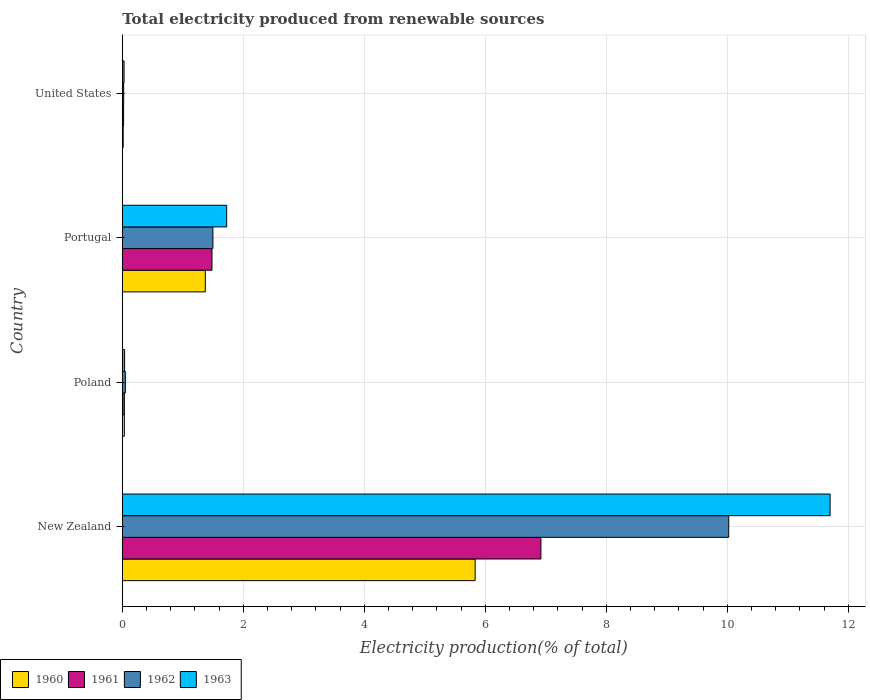Are the number of bars per tick equal to the number of legend labels?
Your answer should be compact. Yes. Are the number of bars on each tick of the Y-axis equal?
Your answer should be very brief. Yes. How many bars are there on the 2nd tick from the top?
Your answer should be compact. 4. What is the total electricity produced in 1963 in New Zealand?
Offer a terse response. 11.7. Across all countries, what is the maximum total electricity produced in 1961?
Make the answer very short. 6.92. Across all countries, what is the minimum total electricity produced in 1961?
Provide a succinct answer. 0.02. In which country was the total electricity produced in 1960 maximum?
Your answer should be compact. New Zealand. In which country was the total electricity produced in 1963 minimum?
Ensure brevity in your answer.  United States. What is the total total electricity produced in 1962 in the graph?
Ensure brevity in your answer.  11.6. What is the difference between the total electricity produced in 1963 in Portugal and that in United States?
Keep it short and to the point. 1.7. What is the difference between the total electricity produced in 1960 in Portugal and the total electricity produced in 1962 in New Zealand?
Keep it short and to the point. -8.65. What is the average total electricity produced in 1963 per country?
Provide a succinct answer. 3.37. What is the difference between the total electricity produced in 1960 and total electricity produced in 1961 in Poland?
Keep it short and to the point. 3.156606850160393e-5. What is the ratio of the total electricity produced in 1961 in Portugal to that in United States?
Your answer should be compact. 68.83. Is the total electricity produced in 1960 in Portugal less than that in United States?
Your response must be concise. No. What is the difference between the highest and the second highest total electricity produced in 1962?
Make the answer very short. 8.53. What is the difference between the highest and the lowest total electricity produced in 1961?
Ensure brevity in your answer.  6.9. In how many countries, is the total electricity produced in 1962 greater than the average total electricity produced in 1962 taken over all countries?
Ensure brevity in your answer.  1. Is it the case that in every country, the sum of the total electricity produced in 1963 and total electricity produced in 1961 is greater than the total electricity produced in 1960?
Keep it short and to the point. Yes. Are all the bars in the graph horizontal?
Make the answer very short. Yes. How many countries are there in the graph?
Give a very brief answer. 4. What is the difference between two consecutive major ticks on the X-axis?
Provide a succinct answer. 2. Are the values on the major ticks of X-axis written in scientific E-notation?
Offer a terse response. No. Does the graph contain grids?
Give a very brief answer. Yes. How many legend labels are there?
Provide a succinct answer. 4. What is the title of the graph?
Offer a terse response. Total electricity produced from renewable sources. What is the label or title of the X-axis?
Make the answer very short. Electricity production(% of total). What is the Electricity production(% of total) in 1960 in New Zealand?
Your answer should be compact. 5.83. What is the Electricity production(% of total) of 1961 in New Zealand?
Give a very brief answer. 6.92. What is the Electricity production(% of total) of 1962 in New Zealand?
Provide a succinct answer. 10.02. What is the Electricity production(% of total) of 1963 in New Zealand?
Your response must be concise. 11.7. What is the Electricity production(% of total) of 1960 in Poland?
Your response must be concise. 0.03. What is the Electricity production(% of total) of 1961 in Poland?
Your response must be concise. 0.03. What is the Electricity production(% of total) of 1962 in Poland?
Keep it short and to the point. 0.05. What is the Electricity production(% of total) of 1963 in Poland?
Your answer should be very brief. 0.04. What is the Electricity production(% of total) of 1960 in Portugal?
Keep it short and to the point. 1.37. What is the Electricity production(% of total) in 1961 in Portugal?
Ensure brevity in your answer.  1.48. What is the Electricity production(% of total) of 1962 in Portugal?
Offer a very short reply. 1.5. What is the Electricity production(% of total) in 1963 in Portugal?
Offer a very short reply. 1.73. What is the Electricity production(% of total) in 1960 in United States?
Make the answer very short. 0.02. What is the Electricity production(% of total) of 1961 in United States?
Keep it short and to the point. 0.02. What is the Electricity production(% of total) in 1962 in United States?
Offer a terse response. 0.02. What is the Electricity production(% of total) of 1963 in United States?
Give a very brief answer. 0.03. Across all countries, what is the maximum Electricity production(% of total) in 1960?
Provide a succinct answer. 5.83. Across all countries, what is the maximum Electricity production(% of total) of 1961?
Provide a succinct answer. 6.92. Across all countries, what is the maximum Electricity production(% of total) in 1962?
Your answer should be compact. 10.02. Across all countries, what is the maximum Electricity production(% of total) in 1963?
Your answer should be compact. 11.7. Across all countries, what is the minimum Electricity production(% of total) of 1960?
Provide a short and direct response. 0.02. Across all countries, what is the minimum Electricity production(% of total) in 1961?
Provide a short and direct response. 0.02. Across all countries, what is the minimum Electricity production(% of total) of 1962?
Your response must be concise. 0.02. Across all countries, what is the minimum Electricity production(% of total) in 1963?
Give a very brief answer. 0.03. What is the total Electricity production(% of total) of 1960 in the graph?
Your answer should be compact. 7.25. What is the total Electricity production(% of total) in 1961 in the graph?
Ensure brevity in your answer.  8.46. What is the total Electricity production(% of total) of 1962 in the graph?
Provide a succinct answer. 11.6. What is the total Electricity production(% of total) in 1963 in the graph?
Offer a very short reply. 13.49. What is the difference between the Electricity production(% of total) of 1960 in New Zealand and that in Poland?
Your answer should be very brief. 5.8. What is the difference between the Electricity production(% of total) of 1961 in New Zealand and that in Poland?
Keep it short and to the point. 6.89. What is the difference between the Electricity production(% of total) in 1962 in New Zealand and that in Poland?
Your answer should be very brief. 9.97. What is the difference between the Electricity production(% of total) in 1963 in New Zealand and that in Poland?
Offer a very short reply. 11.66. What is the difference between the Electricity production(% of total) of 1960 in New Zealand and that in Portugal?
Your answer should be very brief. 4.46. What is the difference between the Electricity production(% of total) in 1961 in New Zealand and that in Portugal?
Provide a succinct answer. 5.44. What is the difference between the Electricity production(% of total) of 1962 in New Zealand and that in Portugal?
Give a very brief answer. 8.53. What is the difference between the Electricity production(% of total) in 1963 in New Zealand and that in Portugal?
Your answer should be very brief. 9.97. What is the difference between the Electricity production(% of total) of 1960 in New Zealand and that in United States?
Provide a short and direct response. 5.82. What is the difference between the Electricity production(% of total) in 1961 in New Zealand and that in United States?
Offer a terse response. 6.9. What is the difference between the Electricity production(% of total) in 1962 in New Zealand and that in United States?
Provide a succinct answer. 10. What is the difference between the Electricity production(% of total) of 1963 in New Zealand and that in United States?
Ensure brevity in your answer.  11.67. What is the difference between the Electricity production(% of total) of 1960 in Poland and that in Portugal?
Your answer should be very brief. -1.34. What is the difference between the Electricity production(% of total) of 1961 in Poland and that in Portugal?
Offer a terse response. -1.45. What is the difference between the Electricity production(% of total) in 1962 in Poland and that in Portugal?
Your response must be concise. -1.45. What is the difference between the Electricity production(% of total) of 1963 in Poland and that in Portugal?
Ensure brevity in your answer.  -1.69. What is the difference between the Electricity production(% of total) of 1960 in Poland and that in United States?
Ensure brevity in your answer.  0.02. What is the difference between the Electricity production(% of total) in 1961 in Poland and that in United States?
Offer a terse response. 0.01. What is the difference between the Electricity production(% of total) in 1962 in Poland and that in United States?
Your answer should be compact. 0.03. What is the difference between the Electricity production(% of total) in 1963 in Poland and that in United States?
Provide a succinct answer. 0.01. What is the difference between the Electricity production(% of total) of 1960 in Portugal and that in United States?
Keep it short and to the point. 1.36. What is the difference between the Electricity production(% of total) of 1961 in Portugal and that in United States?
Your response must be concise. 1.46. What is the difference between the Electricity production(% of total) in 1962 in Portugal and that in United States?
Provide a succinct answer. 1.48. What is the difference between the Electricity production(% of total) of 1963 in Portugal and that in United States?
Give a very brief answer. 1.7. What is the difference between the Electricity production(% of total) of 1960 in New Zealand and the Electricity production(% of total) of 1961 in Poland?
Ensure brevity in your answer.  5.8. What is the difference between the Electricity production(% of total) of 1960 in New Zealand and the Electricity production(% of total) of 1962 in Poland?
Offer a very short reply. 5.78. What is the difference between the Electricity production(% of total) of 1960 in New Zealand and the Electricity production(% of total) of 1963 in Poland?
Offer a terse response. 5.79. What is the difference between the Electricity production(% of total) in 1961 in New Zealand and the Electricity production(% of total) in 1962 in Poland?
Provide a short and direct response. 6.87. What is the difference between the Electricity production(% of total) of 1961 in New Zealand and the Electricity production(% of total) of 1963 in Poland?
Provide a succinct answer. 6.88. What is the difference between the Electricity production(% of total) in 1962 in New Zealand and the Electricity production(% of total) in 1963 in Poland?
Offer a terse response. 9.99. What is the difference between the Electricity production(% of total) of 1960 in New Zealand and the Electricity production(% of total) of 1961 in Portugal?
Offer a very short reply. 4.35. What is the difference between the Electricity production(% of total) of 1960 in New Zealand and the Electricity production(% of total) of 1962 in Portugal?
Your answer should be very brief. 4.33. What is the difference between the Electricity production(% of total) of 1960 in New Zealand and the Electricity production(% of total) of 1963 in Portugal?
Provide a short and direct response. 4.11. What is the difference between the Electricity production(% of total) of 1961 in New Zealand and the Electricity production(% of total) of 1962 in Portugal?
Keep it short and to the point. 5.42. What is the difference between the Electricity production(% of total) of 1961 in New Zealand and the Electricity production(% of total) of 1963 in Portugal?
Your answer should be compact. 5.19. What is the difference between the Electricity production(% of total) in 1962 in New Zealand and the Electricity production(% of total) in 1963 in Portugal?
Your answer should be very brief. 8.3. What is the difference between the Electricity production(% of total) in 1960 in New Zealand and the Electricity production(% of total) in 1961 in United States?
Your answer should be compact. 5.81. What is the difference between the Electricity production(% of total) of 1960 in New Zealand and the Electricity production(% of total) of 1962 in United States?
Offer a very short reply. 5.81. What is the difference between the Electricity production(% of total) in 1960 in New Zealand and the Electricity production(% of total) in 1963 in United States?
Provide a short and direct response. 5.8. What is the difference between the Electricity production(% of total) in 1961 in New Zealand and the Electricity production(% of total) in 1962 in United States?
Provide a succinct answer. 6.9. What is the difference between the Electricity production(% of total) in 1961 in New Zealand and the Electricity production(% of total) in 1963 in United States?
Your response must be concise. 6.89. What is the difference between the Electricity production(% of total) of 1962 in New Zealand and the Electricity production(% of total) of 1963 in United States?
Provide a short and direct response. 10. What is the difference between the Electricity production(% of total) of 1960 in Poland and the Electricity production(% of total) of 1961 in Portugal?
Keep it short and to the point. -1.45. What is the difference between the Electricity production(% of total) of 1960 in Poland and the Electricity production(% of total) of 1962 in Portugal?
Your response must be concise. -1.46. What is the difference between the Electricity production(% of total) in 1960 in Poland and the Electricity production(% of total) in 1963 in Portugal?
Provide a succinct answer. -1.69. What is the difference between the Electricity production(% of total) in 1961 in Poland and the Electricity production(% of total) in 1962 in Portugal?
Your response must be concise. -1.46. What is the difference between the Electricity production(% of total) of 1961 in Poland and the Electricity production(% of total) of 1963 in Portugal?
Offer a very short reply. -1.69. What is the difference between the Electricity production(% of total) in 1962 in Poland and the Electricity production(% of total) in 1963 in Portugal?
Your answer should be compact. -1.67. What is the difference between the Electricity production(% of total) in 1960 in Poland and the Electricity production(% of total) in 1961 in United States?
Provide a short and direct response. 0.01. What is the difference between the Electricity production(% of total) of 1960 in Poland and the Electricity production(% of total) of 1962 in United States?
Ensure brevity in your answer.  0.01. What is the difference between the Electricity production(% of total) of 1960 in Poland and the Electricity production(% of total) of 1963 in United States?
Provide a short and direct response. 0. What is the difference between the Electricity production(% of total) in 1961 in Poland and the Electricity production(% of total) in 1962 in United States?
Give a very brief answer. 0.01. What is the difference between the Electricity production(% of total) of 1961 in Poland and the Electricity production(% of total) of 1963 in United States?
Make the answer very short. 0. What is the difference between the Electricity production(% of total) in 1962 in Poland and the Electricity production(% of total) in 1963 in United States?
Offer a terse response. 0.02. What is the difference between the Electricity production(% of total) of 1960 in Portugal and the Electricity production(% of total) of 1961 in United States?
Provide a succinct answer. 1.35. What is the difference between the Electricity production(% of total) in 1960 in Portugal and the Electricity production(% of total) in 1962 in United States?
Make the answer very short. 1.35. What is the difference between the Electricity production(% of total) of 1960 in Portugal and the Electricity production(% of total) of 1963 in United States?
Provide a succinct answer. 1.34. What is the difference between the Electricity production(% of total) in 1961 in Portugal and the Electricity production(% of total) in 1962 in United States?
Your answer should be compact. 1.46. What is the difference between the Electricity production(% of total) in 1961 in Portugal and the Electricity production(% of total) in 1963 in United States?
Keep it short and to the point. 1.45. What is the difference between the Electricity production(% of total) in 1962 in Portugal and the Electricity production(% of total) in 1963 in United States?
Offer a terse response. 1.47. What is the average Electricity production(% of total) of 1960 per country?
Give a very brief answer. 1.81. What is the average Electricity production(% of total) in 1961 per country?
Ensure brevity in your answer.  2.11. What is the average Electricity production(% of total) of 1962 per country?
Ensure brevity in your answer.  2.9. What is the average Electricity production(% of total) in 1963 per country?
Give a very brief answer. 3.37. What is the difference between the Electricity production(% of total) in 1960 and Electricity production(% of total) in 1961 in New Zealand?
Ensure brevity in your answer.  -1.09. What is the difference between the Electricity production(% of total) of 1960 and Electricity production(% of total) of 1962 in New Zealand?
Offer a very short reply. -4.19. What is the difference between the Electricity production(% of total) in 1960 and Electricity production(% of total) in 1963 in New Zealand?
Offer a terse response. -5.87. What is the difference between the Electricity production(% of total) in 1961 and Electricity production(% of total) in 1962 in New Zealand?
Give a very brief answer. -3.1. What is the difference between the Electricity production(% of total) of 1961 and Electricity production(% of total) of 1963 in New Zealand?
Make the answer very short. -4.78. What is the difference between the Electricity production(% of total) of 1962 and Electricity production(% of total) of 1963 in New Zealand?
Make the answer very short. -1.68. What is the difference between the Electricity production(% of total) in 1960 and Electricity production(% of total) in 1962 in Poland?
Your response must be concise. -0.02. What is the difference between the Electricity production(% of total) in 1960 and Electricity production(% of total) in 1963 in Poland?
Ensure brevity in your answer.  -0. What is the difference between the Electricity production(% of total) in 1961 and Electricity production(% of total) in 1962 in Poland?
Your response must be concise. -0.02. What is the difference between the Electricity production(% of total) of 1961 and Electricity production(% of total) of 1963 in Poland?
Make the answer very short. -0. What is the difference between the Electricity production(% of total) in 1962 and Electricity production(% of total) in 1963 in Poland?
Make the answer very short. 0.01. What is the difference between the Electricity production(% of total) of 1960 and Electricity production(% of total) of 1961 in Portugal?
Provide a short and direct response. -0.11. What is the difference between the Electricity production(% of total) in 1960 and Electricity production(% of total) in 1962 in Portugal?
Make the answer very short. -0.13. What is the difference between the Electricity production(% of total) in 1960 and Electricity production(% of total) in 1963 in Portugal?
Your answer should be very brief. -0.35. What is the difference between the Electricity production(% of total) of 1961 and Electricity production(% of total) of 1962 in Portugal?
Ensure brevity in your answer.  -0.02. What is the difference between the Electricity production(% of total) of 1961 and Electricity production(% of total) of 1963 in Portugal?
Provide a succinct answer. -0.24. What is the difference between the Electricity production(% of total) in 1962 and Electricity production(% of total) in 1963 in Portugal?
Your response must be concise. -0.23. What is the difference between the Electricity production(% of total) in 1960 and Electricity production(% of total) in 1961 in United States?
Provide a short and direct response. -0.01. What is the difference between the Electricity production(% of total) in 1960 and Electricity production(% of total) in 1962 in United States?
Offer a very short reply. -0.01. What is the difference between the Electricity production(% of total) of 1960 and Electricity production(% of total) of 1963 in United States?
Ensure brevity in your answer.  -0.01. What is the difference between the Electricity production(% of total) of 1961 and Electricity production(% of total) of 1962 in United States?
Keep it short and to the point. -0. What is the difference between the Electricity production(% of total) of 1961 and Electricity production(% of total) of 1963 in United States?
Offer a very short reply. -0.01. What is the difference between the Electricity production(% of total) of 1962 and Electricity production(% of total) of 1963 in United States?
Ensure brevity in your answer.  -0.01. What is the ratio of the Electricity production(% of total) of 1960 in New Zealand to that in Poland?
Make the answer very short. 170.79. What is the ratio of the Electricity production(% of total) of 1961 in New Zealand to that in Poland?
Offer a very short reply. 202.83. What is the ratio of the Electricity production(% of total) of 1962 in New Zealand to that in Poland?
Provide a short and direct response. 196.95. What is the ratio of the Electricity production(% of total) of 1963 in New Zealand to that in Poland?
Your response must be concise. 308.73. What is the ratio of the Electricity production(% of total) of 1960 in New Zealand to that in Portugal?
Keep it short and to the point. 4.25. What is the ratio of the Electricity production(% of total) of 1961 in New Zealand to that in Portugal?
Provide a short and direct response. 4.67. What is the ratio of the Electricity production(% of total) of 1962 in New Zealand to that in Portugal?
Your answer should be compact. 6.69. What is the ratio of the Electricity production(% of total) in 1963 in New Zealand to that in Portugal?
Provide a succinct answer. 6.78. What is the ratio of the Electricity production(% of total) in 1960 in New Zealand to that in United States?
Give a very brief answer. 382.31. What is the ratio of the Electricity production(% of total) of 1961 in New Zealand to that in United States?
Keep it short and to the point. 321.25. What is the ratio of the Electricity production(% of total) in 1962 in New Zealand to that in United States?
Your answer should be compact. 439.93. What is the ratio of the Electricity production(% of total) of 1963 in New Zealand to that in United States?
Give a very brief answer. 397.5. What is the ratio of the Electricity production(% of total) in 1960 in Poland to that in Portugal?
Your response must be concise. 0.02. What is the ratio of the Electricity production(% of total) in 1961 in Poland to that in Portugal?
Offer a very short reply. 0.02. What is the ratio of the Electricity production(% of total) of 1962 in Poland to that in Portugal?
Your answer should be very brief. 0.03. What is the ratio of the Electricity production(% of total) in 1963 in Poland to that in Portugal?
Provide a succinct answer. 0.02. What is the ratio of the Electricity production(% of total) in 1960 in Poland to that in United States?
Make the answer very short. 2.24. What is the ratio of the Electricity production(% of total) of 1961 in Poland to that in United States?
Make the answer very short. 1.58. What is the ratio of the Electricity production(% of total) of 1962 in Poland to that in United States?
Ensure brevity in your answer.  2.23. What is the ratio of the Electricity production(% of total) in 1963 in Poland to that in United States?
Keep it short and to the point. 1.29. What is the ratio of the Electricity production(% of total) of 1960 in Portugal to that in United States?
Your answer should be very brief. 89.96. What is the ratio of the Electricity production(% of total) of 1961 in Portugal to that in United States?
Ensure brevity in your answer.  68.83. What is the ratio of the Electricity production(% of total) of 1962 in Portugal to that in United States?
Provide a short and direct response. 65.74. What is the ratio of the Electricity production(% of total) in 1963 in Portugal to that in United States?
Ensure brevity in your answer.  58.63. What is the difference between the highest and the second highest Electricity production(% of total) of 1960?
Provide a short and direct response. 4.46. What is the difference between the highest and the second highest Electricity production(% of total) of 1961?
Offer a very short reply. 5.44. What is the difference between the highest and the second highest Electricity production(% of total) of 1962?
Give a very brief answer. 8.53. What is the difference between the highest and the second highest Electricity production(% of total) of 1963?
Your answer should be very brief. 9.97. What is the difference between the highest and the lowest Electricity production(% of total) of 1960?
Provide a short and direct response. 5.82. What is the difference between the highest and the lowest Electricity production(% of total) of 1961?
Ensure brevity in your answer.  6.9. What is the difference between the highest and the lowest Electricity production(% of total) in 1962?
Keep it short and to the point. 10. What is the difference between the highest and the lowest Electricity production(% of total) of 1963?
Your response must be concise. 11.67. 